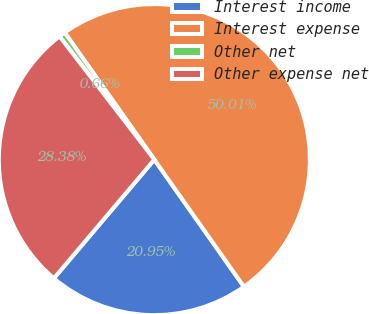Convert chart to OTSL. <chart><loc_0><loc_0><loc_500><loc_500><pie_chart><fcel>Interest income<fcel>Interest expense<fcel>Other net<fcel>Other expense net<nl><fcel>20.95%<fcel>50.0%<fcel>0.66%<fcel>28.38%<nl></chart> 